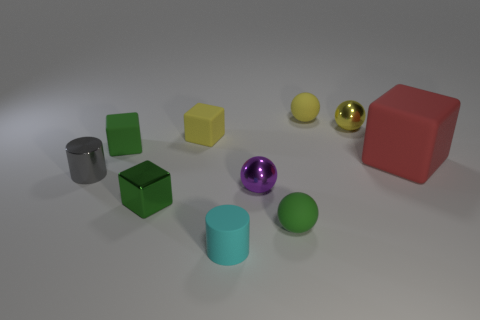There is a small rubber ball that is in front of the tiny shiny cylinder; is it the same color as the small shiny cube?
Make the answer very short. Yes. What is the color of the object that is to the left of the small yellow block and in front of the purple metallic sphere?
Offer a very short reply. Green. Is there another tiny gray thing made of the same material as the small gray thing?
Keep it short and to the point. No. The red thing is what size?
Offer a very short reply. Large. There is a yellow rubber thing on the right side of the yellow thing in front of the yellow metallic sphere; what size is it?
Offer a terse response. Small. There is another small object that is the same shape as the small cyan object; what is its material?
Provide a short and direct response. Metal. What number of green matte spheres are there?
Your response must be concise. 1. There is a tiny cylinder that is to the left of the tiny cylinder right of the block in front of the red thing; what color is it?
Offer a terse response. Gray. Is the number of tiny metal cylinders less than the number of tiny cylinders?
Provide a short and direct response. Yes. What is the color of the large object that is the same shape as the tiny green metallic object?
Offer a terse response. Red. 